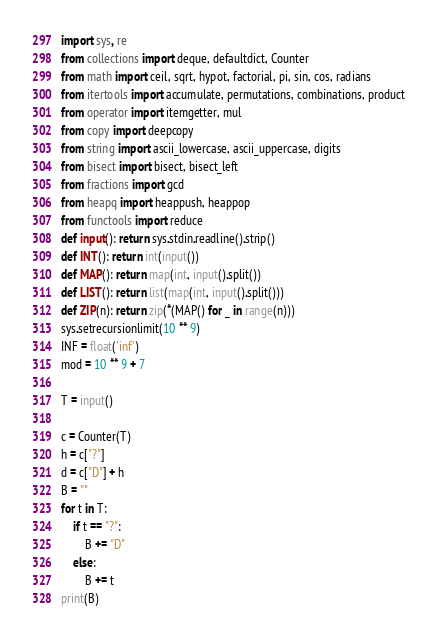Convert code to text. <code><loc_0><loc_0><loc_500><loc_500><_Python_>import sys, re
from collections import deque, defaultdict, Counter
from math import ceil, sqrt, hypot, factorial, pi, sin, cos, radians
from itertools import accumulate, permutations, combinations, product
from operator import itemgetter, mul
from copy import deepcopy
from string import ascii_lowercase, ascii_uppercase, digits
from bisect import bisect, bisect_left
from fractions import gcd
from heapq import heappush, heappop
from functools import reduce
def input(): return sys.stdin.readline().strip()
def INT(): return int(input())
def MAP(): return map(int, input().split())
def LIST(): return list(map(int, input().split()))
def ZIP(n): return zip(*(MAP() for _ in range(n)))
sys.setrecursionlimit(10 ** 9)
INF = float('inf')
mod = 10 ** 9 + 7

T = input()

c = Counter(T)
h = c["?"]
d = c["D"] + h
B = ""
for t in T:
    if t == "?":
        B += "D"
    else:
        B += t
print(B)
</code> 